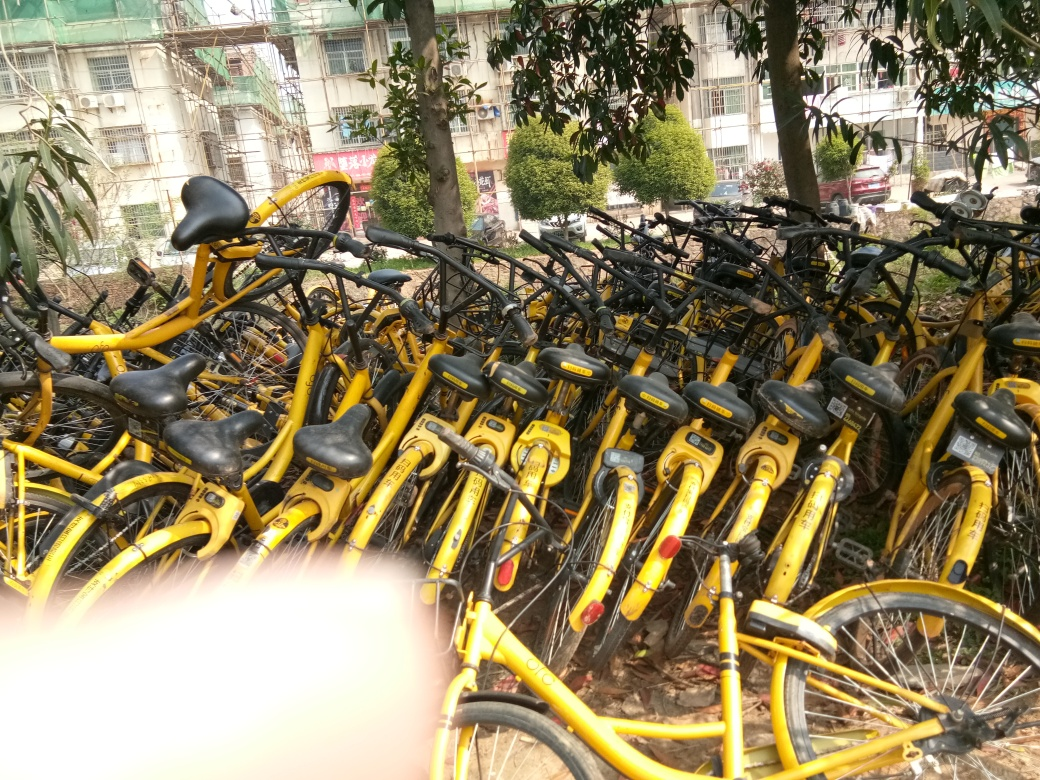Is the lighting sufficient?
A. Yes
B. No
Answer with the option's letter from the given choices directly.
 A. 